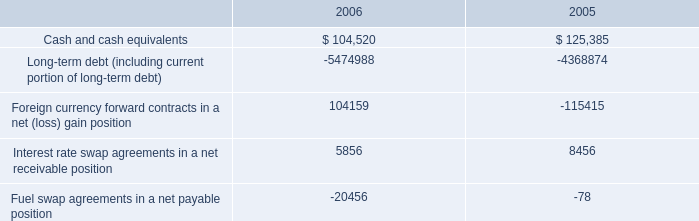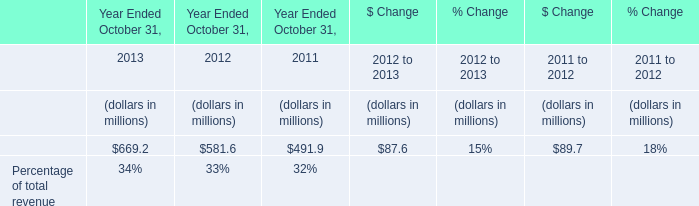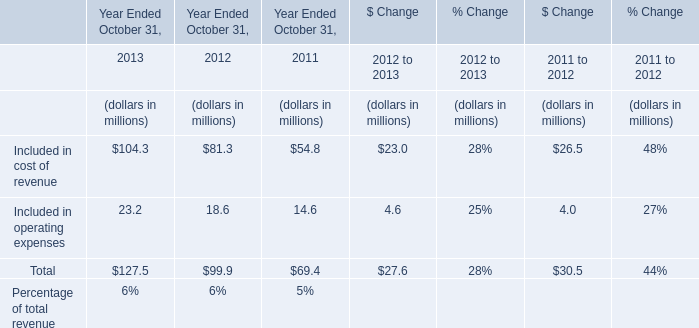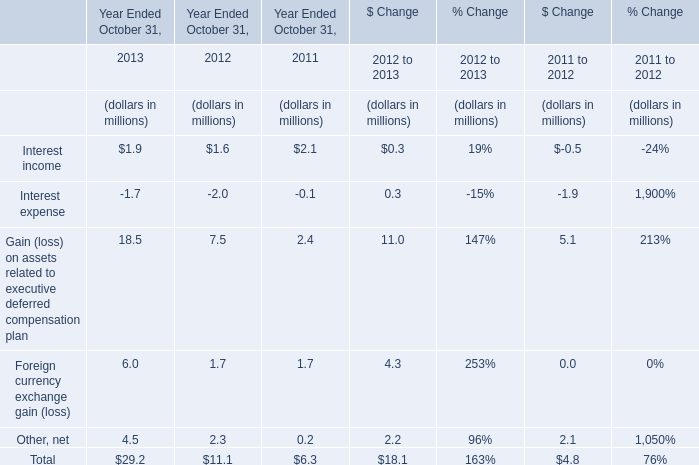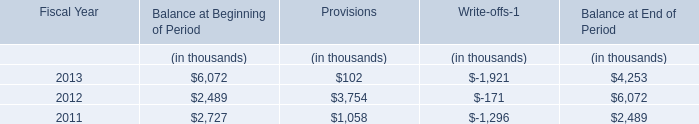How many kinds of Year Ended October 31, are greater than 0 in 2013? 
Answer: 4. 